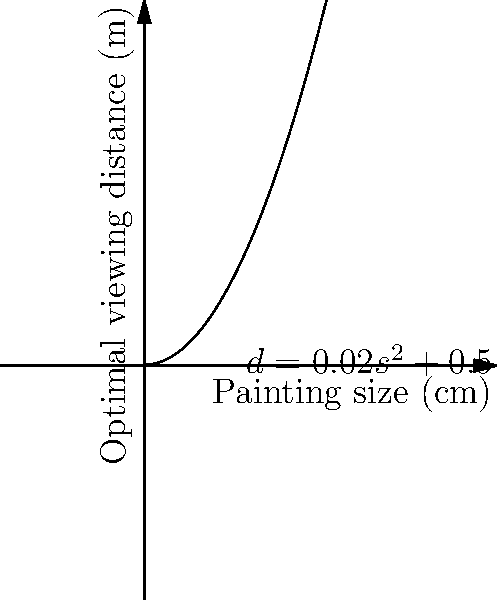An Impressionist painting's optimal viewing distance (d) in meters is related to its size (s) in centimeters by the function $d = 0.02s^2 + 0.5$. If a Monet water lily painting measures 200 cm in width, what is the recommended viewing distance to fully appreciate the interplay of light and color? To solve this problem, we need to follow these steps:

1. Identify the given function: $d = 0.02s^2 + 0.5$
   Where d is the optimal viewing distance in meters and s is the painting size in centimeters.

2. Identify the given information: The painting size (s) is 200 cm.

3. Substitute the painting size into the function:
   $d = 0.02(200)^2 + 0.5$

4. Calculate the square of 200:
   $d = 0.02(40,000) + 0.5$

5. Multiply 0.02 by 40,000:
   $d = 800 + 0.5$

6. Add the final terms:
   $d = 800.5$

Therefore, the optimal viewing distance for the 200 cm wide Monet water lily painting is 800.5 meters.
Answer: 800.5 meters 